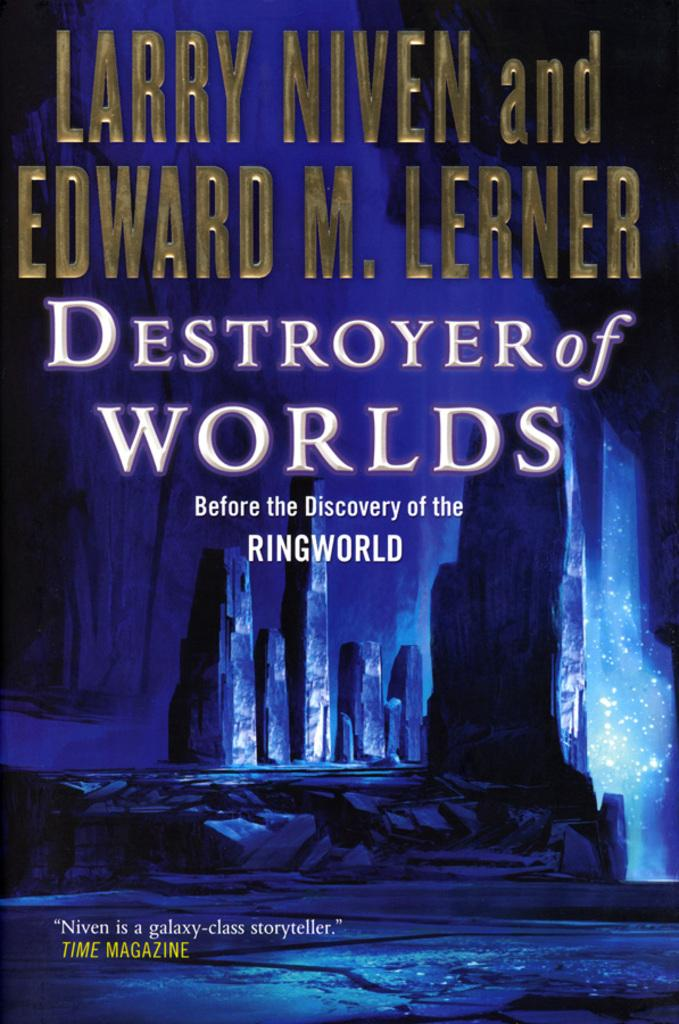<image>
Share a concise interpretation of the image provided. Larry Niven and Edward M. Lerner wrote Destroyer of Worlds together 